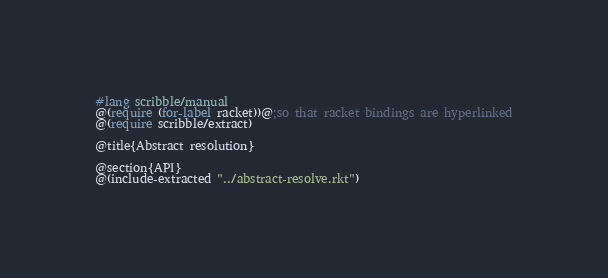Convert code to text. <code><loc_0><loc_0><loc_500><loc_500><_Racket_>#lang scribble/manual
@(require (for-label racket))@;so that racket bindings are hyperlinked
@(require scribble/extract)

@title{Abstract resolution}

@section{API}
@(include-extracted "../abstract-resolve.rkt")
</code> 